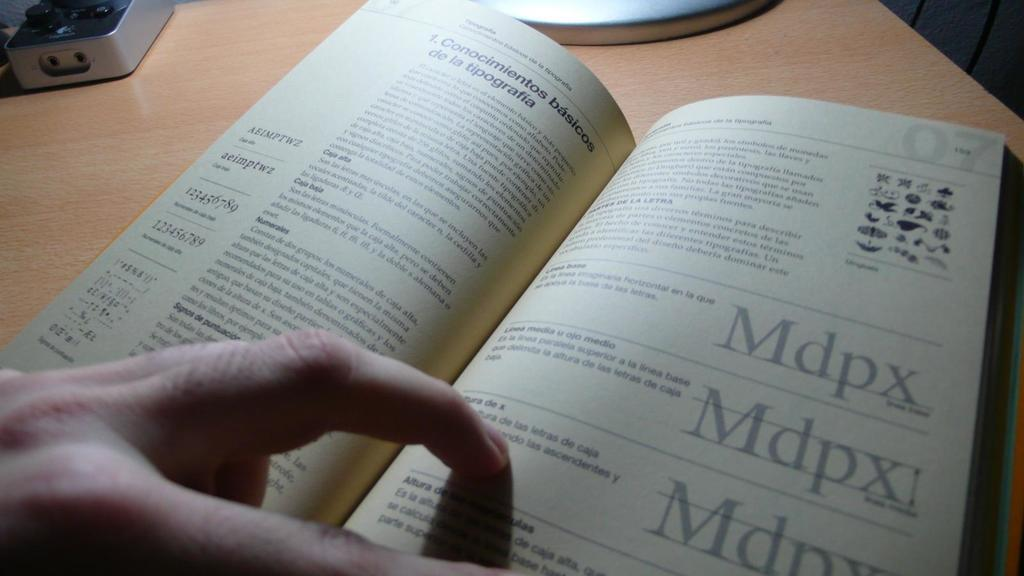<image>
Describe the image concisely. Person reading a book on a page that has the letters "MDPX". 